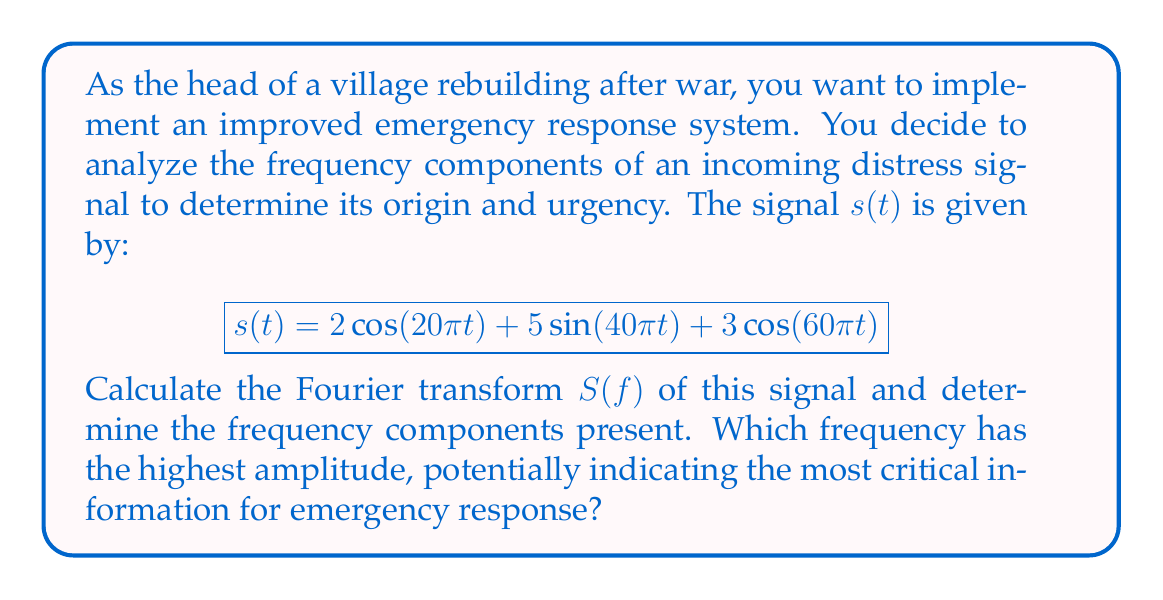Provide a solution to this math problem. To solve this problem, we need to apply the Fourier transform to the given signal $s(t)$. The Fourier transform converts a time-domain signal into its frequency-domain representation.

1) First, recall the Fourier transform pairs for cosine and sine functions:

   $\cos(2\pi f_0 t) \leftrightarrow \frac{1}{2}[\delta(f-f_0) + \delta(f+f_0)]$
   $\sin(2\pi f_0 t) \leftrightarrow \frac{j}{2}[\delta(f-f_0) - \delta(f+f_0)]$

   Where $\delta(f)$ is the Dirac delta function.

2) Now, let's break down our signal:

   $s(t) = 2\cos(20\pi t) + 5\sin(40\pi t) + 3\cos(60\pi t)$

3) We can rewrite this in terms of frequency:

   $s(t) = 2\cos(2\pi \cdot 10t) + 5\sin(2\pi \cdot 20t) + 3\cos(2\pi \cdot 30t)$

4) Now, we can apply the Fourier transform to each term:

   $S(f) = 2 \cdot \frac{1}{2}[\delta(f-10) + \delta(f+10)] + 5 \cdot \frac{j}{2}[\delta(f-20) - \delta(f+20)] + 3 \cdot \frac{1}{2}[\delta(f-30) + \delta(f+30)]$

5) Simplifying:

   $S(f) = [\delta(f-10) + \delta(f+10)] + \frac{5j}{2}[\delta(f-20) - \delta(f+20)] + \frac{3}{2}[\delta(f-30) + \delta(f+30)]$

6) This result shows us the frequency components present in the signal:
   - 10 Hz with amplitude 1
   - 20 Hz with amplitude 5/2
   - 30 Hz with amplitude 3/2

7) To find the frequency with the highest amplitude, we compare the absolute values:
   10 Hz: |1| = 1
   20 Hz: |5j/2| = 5/2 = 2.5
   30 Hz: |3/2| = 1.5

The 20 Hz component has the highest amplitude of 2.5.
Answer: The Fourier transform of the signal is:

$$S(f) = [\delta(f-10) + \delta(f+10)] + \frac{5j}{2}[\delta(f-20) - \delta(f+20)] + \frac{3}{2}[\delta(f-30) + \delta(f+30)]$$

The frequency components present are 10 Hz, 20 Hz, and 30 Hz. The 20 Hz component has the highest amplitude of 2.5, potentially indicating the most critical information for emergency response. 